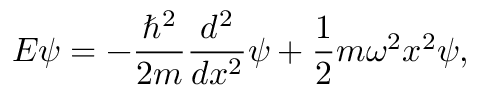<formula> <loc_0><loc_0><loc_500><loc_500>E \psi = - { \frac { \hbar { ^ } { 2 } } { 2 m } } { \frac { d ^ { 2 } } { d x ^ { 2 } } } \psi + { \frac { 1 } { 2 } } m \omega ^ { 2 } x ^ { 2 } \psi ,</formula> 